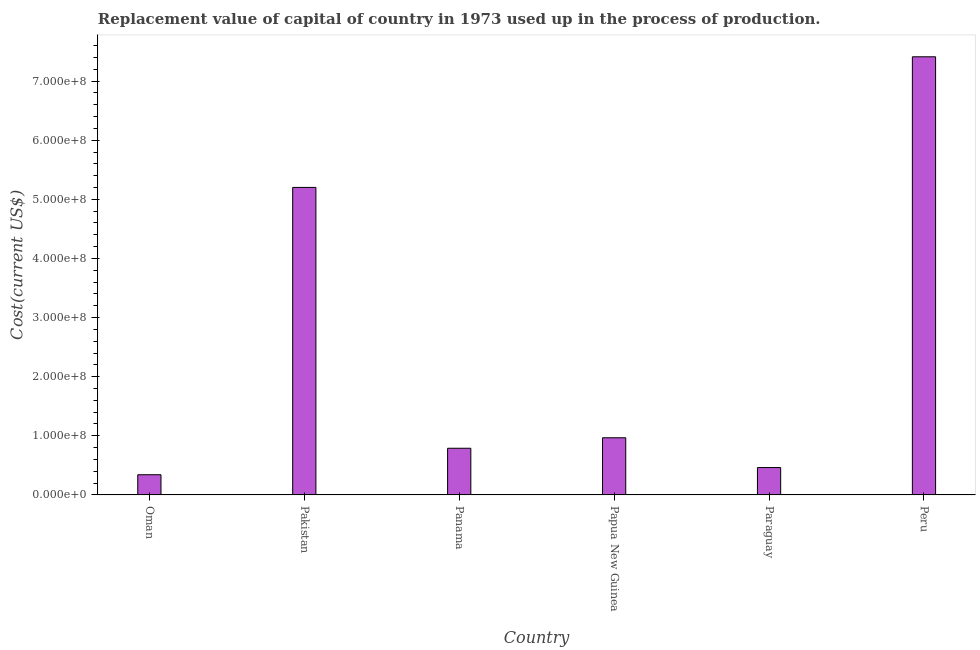Does the graph contain grids?
Ensure brevity in your answer.  No. What is the title of the graph?
Ensure brevity in your answer.  Replacement value of capital of country in 1973 used up in the process of production. What is the label or title of the X-axis?
Provide a succinct answer. Country. What is the label or title of the Y-axis?
Provide a succinct answer. Cost(current US$). What is the consumption of fixed capital in Oman?
Your answer should be very brief. 3.42e+07. Across all countries, what is the maximum consumption of fixed capital?
Offer a very short reply. 7.41e+08. Across all countries, what is the minimum consumption of fixed capital?
Offer a terse response. 3.42e+07. In which country was the consumption of fixed capital minimum?
Provide a succinct answer. Oman. What is the sum of the consumption of fixed capital?
Offer a very short reply. 1.52e+09. What is the difference between the consumption of fixed capital in Pakistan and Paraguay?
Keep it short and to the point. 4.74e+08. What is the average consumption of fixed capital per country?
Ensure brevity in your answer.  2.53e+08. What is the median consumption of fixed capital?
Keep it short and to the point. 8.78e+07. In how many countries, is the consumption of fixed capital greater than 640000000 US$?
Offer a very short reply. 1. What is the ratio of the consumption of fixed capital in Oman to that in Pakistan?
Your answer should be very brief. 0.07. What is the difference between the highest and the second highest consumption of fixed capital?
Provide a succinct answer. 2.21e+08. Is the sum of the consumption of fixed capital in Panama and Papua New Guinea greater than the maximum consumption of fixed capital across all countries?
Offer a terse response. No. What is the difference between the highest and the lowest consumption of fixed capital?
Provide a succinct answer. 7.07e+08. In how many countries, is the consumption of fixed capital greater than the average consumption of fixed capital taken over all countries?
Offer a terse response. 2. Are all the bars in the graph horizontal?
Provide a succinct answer. No. What is the difference between two consecutive major ticks on the Y-axis?
Give a very brief answer. 1.00e+08. Are the values on the major ticks of Y-axis written in scientific E-notation?
Your response must be concise. Yes. What is the Cost(current US$) of Oman?
Ensure brevity in your answer.  3.42e+07. What is the Cost(current US$) in Pakistan?
Provide a succinct answer. 5.20e+08. What is the Cost(current US$) of Panama?
Your response must be concise. 7.90e+07. What is the Cost(current US$) in Papua New Guinea?
Your response must be concise. 9.67e+07. What is the Cost(current US$) in Paraguay?
Your answer should be compact. 4.63e+07. What is the Cost(current US$) of Peru?
Ensure brevity in your answer.  7.41e+08. What is the difference between the Cost(current US$) in Oman and Pakistan?
Your answer should be very brief. -4.86e+08. What is the difference between the Cost(current US$) in Oman and Panama?
Ensure brevity in your answer.  -4.48e+07. What is the difference between the Cost(current US$) in Oman and Papua New Guinea?
Provide a succinct answer. -6.25e+07. What is the difference between the Cost(current US$) in Oman and Paraguay?
Ensure brevity in your answer.  -1.22e+07. What is the difference between the Cost(current US$) in Oman and Peru?
Your response must be concise. -7.07e+08. What is the difference between the Cost(current US$) in Pakistan and Panama?
Offer a very short reply. 4.41e+08. What is the difference between the Cost(current US$) in Pakistan and Papua New Guinea?
Keep it short and to the point. 4.23e+08. What is the difference between the Cost(current US$) in Pakistan and Paraguay?
Ensure brevity in your answer.  4.74e+08. What is the difference between the Cost(current US$) in Pakistan and Peru?
Offer a terse response. -2.21e+08. What is the difference between the Cost(current US$) in Panama and Papua New Guinea?
Your answer should be compact. -1.77e+07. What is the difference between the Cost(current US$) in Panama and Paraguay?
Your answer should be very brief. 3.26e+07. What is the difference between the Cost(current US$) in Panama and Peru?
Make the answer very short. -6.62e+08. What is the difference between the Cost(current US$) in Papua New Guinea and Paraguay?
Give a very brief answer. 5.04e+07. What is the difference between the Cost(current US$) in Papua New Guinea and Peru?
Offer a very short reply. -6.44e+08. What is the difference between the Cost(current US$) in Paraguay and Peru?
Keep it short and to the point. -6.95e+08. What is the ratio of the Cost(current US$) in Oman to that in Pakistan?
Make the answer very short. 0.07. What is the ratio of the Cost(current US$) in Oman to that in Panama?
Ensure brevity in your answer.  0.43. What is the ratio of the Cost(current US$) in Oman to that in Papua New Guinea?
Offer a very short reply. 0.35. What is the ratio of the Cost(current US$) in Oman to that in Paraguay?
Your response must be concise. 0.74. What is the ratio of the Cost(current US$) in Oman to that in Peru?
Offer a very short reply. 0.05. What is the ratio of the Cost(current US$) in Pakistan to that in Panama?
Keep it short and to the point. 6.59. What is the ratio of the Cost(current US$) in Pakistan to that in Papua New Guinea?
Give a very brief answer. 5.38. What is the ratio of the Cost(current US$) in Pakistan to that in Paraguay?
Provide a short and direct response. 11.23. What is the ratio of the Cost(current US$) in Pakistan to that in Peru?
Offer a terse response. 0.7. What is the ratio of the Cost(current US$) in Panama to that in Papua New Guinea?
Keep it short and to the point. 0.82. What is the ratio of the Cost(current US$) in Panama to that in Paraguay?
Make the answer very short. 1.71. What is the ratio of the Cost(current US$) in Panama to that in Peru?
Provide a short and direct response. 0.11. What is the ratio of the Cost(current US$) in Papua New Guinea to that in Paraguay?
Your answer should be compact. 2.09. What is the ratio of the Cost(current US$) in Papua New Guinea to that in Peru?
Provide a succinct answer. 0.13. What is the ratio of the Cost(current US$) in Paraguay to that in Peru?
Offer a terse response. 0.06. 